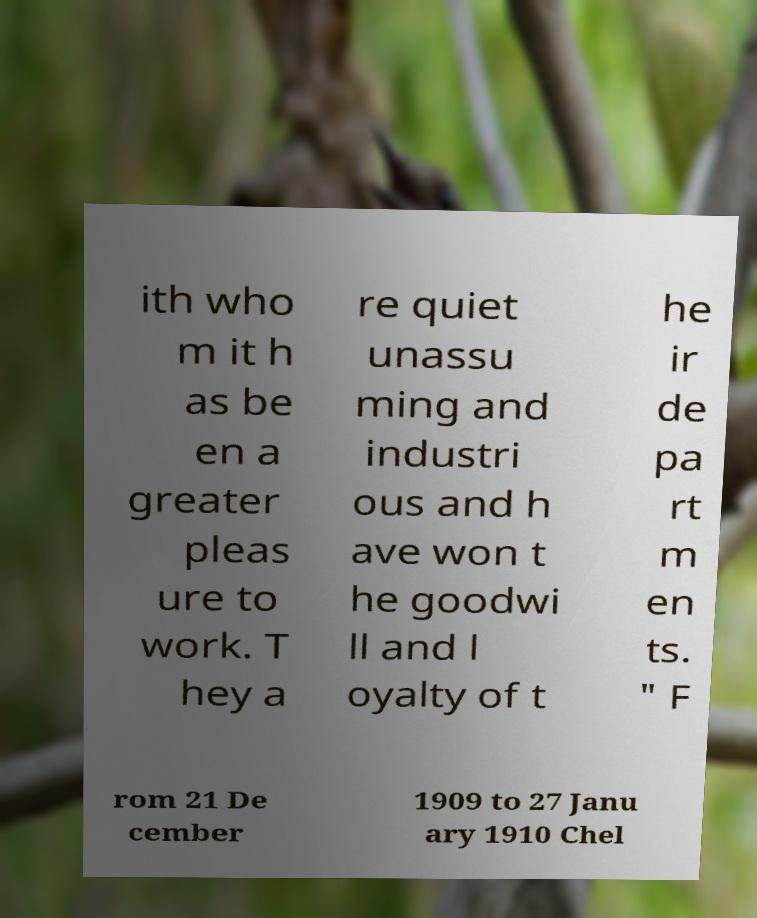For documentation purposes, I need the text within this image transcribed. Could you provide that? ith who m it h as be en a greater pleas ure to work. T hey a re quiet unassu ming and industri ous and h ave won t he goodwi ll and l oyalty of t he ir de pa rt m en ts. " F rom 21 De cember 1909 to 27 Janu ary 1910 Chel 